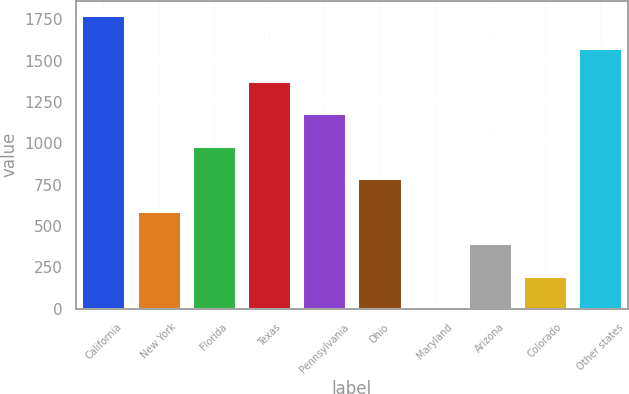<chart> <loc_0><loc_0><loc_500><loc_500><bar_chart><fcel>California<fcel>New York<fcel>Florida<fcel>Texas<fcel>Pennsylvania<fcel>Ohio<fcel>Maryland<fcel>Arizona<fcel>Colorado<fcel>Other states<nl><fcel>1773.1<fcel>591.7<fcel>985.5<fcel>1379.3<fcel>1182.4<fcel>788.6<fcel>1<fcel>394.8<fcel>197.9<fcel>1576.2<nl></chart> 